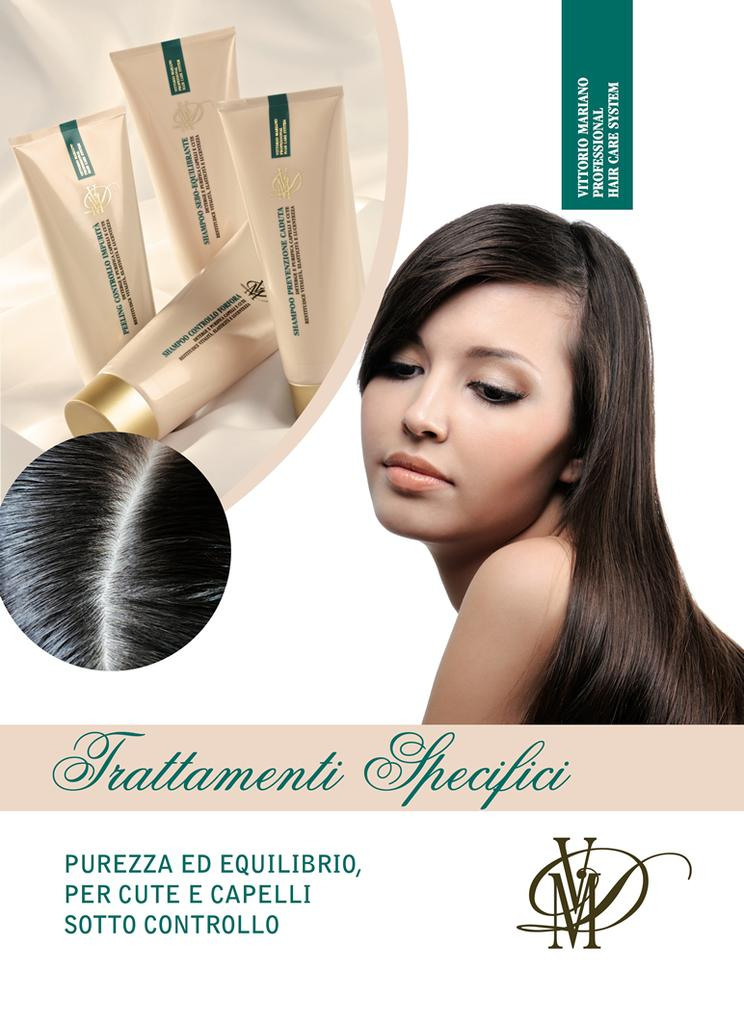<image>
Provide a brief description of the given image. The woman is a model for the hair care brand Trattamentii 